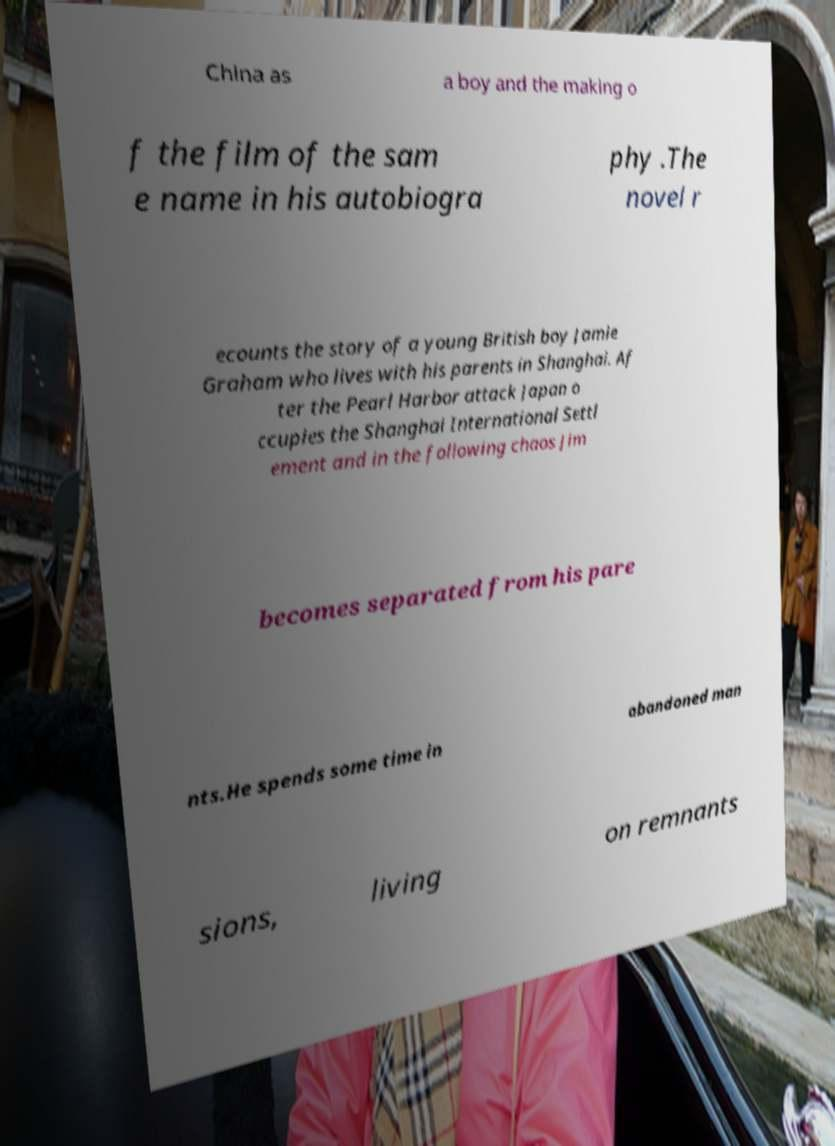What messages or text are displayed in this image? I need them in a readable, typed format. China as a boy and the making o f the film of the sam e name in his autobiogra phy .The novel r ecounts the story of a young British boy Jamie Graham who lives with his parents in Shanghai. Af ter the Pearl Harbor attack Japan o ccupies the Shanghai International Settl ement and in the following chaos Jim becomes separated from his pare nts.He spends some time in abandoned man sions, living on remnants 